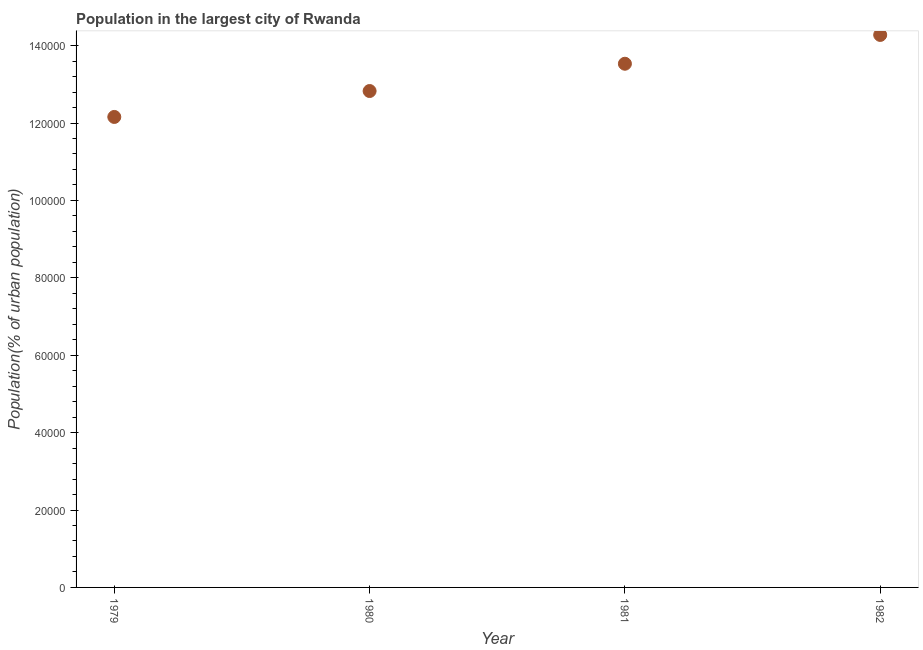What is the population in largest city in 1982?
Provide a short and direct response. 1.43e+05. Across all years, what is the maximum population in largest city?
Offer a terse response. 1.43e+05. Across all years, what is the minimum population in largest city?
Offer a terse response. 1.22e+05. In which year was the population in largest city minimum?
Your response must be concise. 1979. What is the sum of the population in largest city?
Provide a short and direct response. 5.28e+05. What is the difference between the population in largest city in 1979 and 1982?
Make the answer very short. -2.12e+04. What is the average population in largest city per year?
Keep it short and to the point. 1.32e+05. What is the median population in largest city?
Offer a very short reply. 1.32e+05. What is the ratio of the population in largest city in 1980 to that in 1981?
Your answer should be compact. 0.95. Is the population in largest city in 1980 less than that in 1981?
Your answer should be very brief. Yes. What is the difference between the highest and the second highest population in largest city?
Make the answer very short. 7446. What is the difference between the highest and the lowest population in largest city?
Your answer should be very brief. 2.12e+04. How many dotlines are there?
Provide a succinct answer. 1. How many years are there in the graph?
Give a very brief answer. 4. Are the values on the major ticks of Y-axis written in scientific E-notation?
Provide a succinct answer. No. What is the title of the graph?
Your answer should be compact. Population in the largest city of Rwanda. What is the label or title of the X-axis?
Ensure brevity in your answer.  Year. What is the label or title of the Y-axis?
Make the answer very short. Population(% of urban population). What is the Population(% of urban population) in 1979?
Make the answer very short. 1.22e+05. What is the Population(% of urban population) in 1980?
Your answer should be very brief. 1.28e+05. What is the Population(% of urban population) in 1981?
Offer a terse response. 1.35e+05. What is the Population(% of urban population) in 1982?
Give a very brief answer. 1.43e+05. What is the difference between the Population(% of urban population) in 1979 and 1980?
Give a very brief answer. -6699. What is the difference between the Population(% of urban population) in 1979 and 1981?
Your answer should be very brief. -1.37e+04. What is the difference between the Population(% of urban population) in 1979 and 1982?
Make the answer very short. -2.12e+04. What is the difference between the Population(% of urban population) in 1980 and 1981?
Offer a terse response. -7049. What is the difference between the Population(% of urban population) in 1980 and 1982?
Provide a succinct answer. -1.45e+04. What is the difference between the Population(% of urban population) in 1981 and 1982?
Your answer should be compact. -7446. What is the ratio of the Population(% of urban population) in 1979 to that in 1980?
Provide a short and direct response. 0.95. What is the ratio of the Population(% of urban population) in 1979 to that in 1981?
Your response must be concise. 0.9. What is the ratio of the Population(% of urban population) in 1979 to that in 1982?
Your response must be concise. 0.85. What is the ratio of the Population(% of urban population) in 1980 to that in 1981?
Give a very brief answer. 0.95. What is the ratio of the Population(% of urban population) in 1980 to that in 1982?
Offer a terse response. 0.9. What is the ratio of the Population(% of urban population) in 1981 to that in 1982?
Your answer should be very brief. 0.95. 